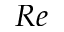Convert formula to latex. <formula><loc_0><loc_0><loc_500><loc_500>R e</formula> 